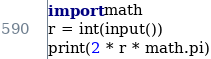Convert code to text. <code><loc_0><loc_0><loc_500><loc_500><_Python_>import math
r = int(input())
print(2 * r * math.pi)</code> 